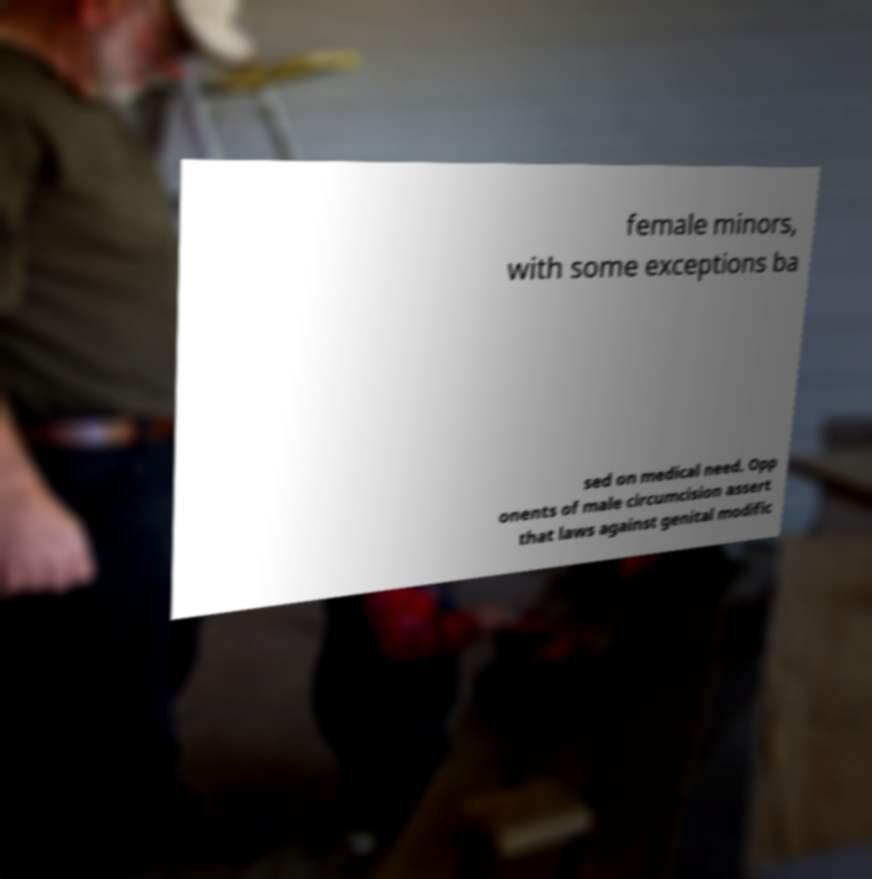I need the written content from this picture converted into text. Can you do that? female minors, with some exceptions ba sed on medical need. Opp onents of male circumcision assert that laws against genital modific 